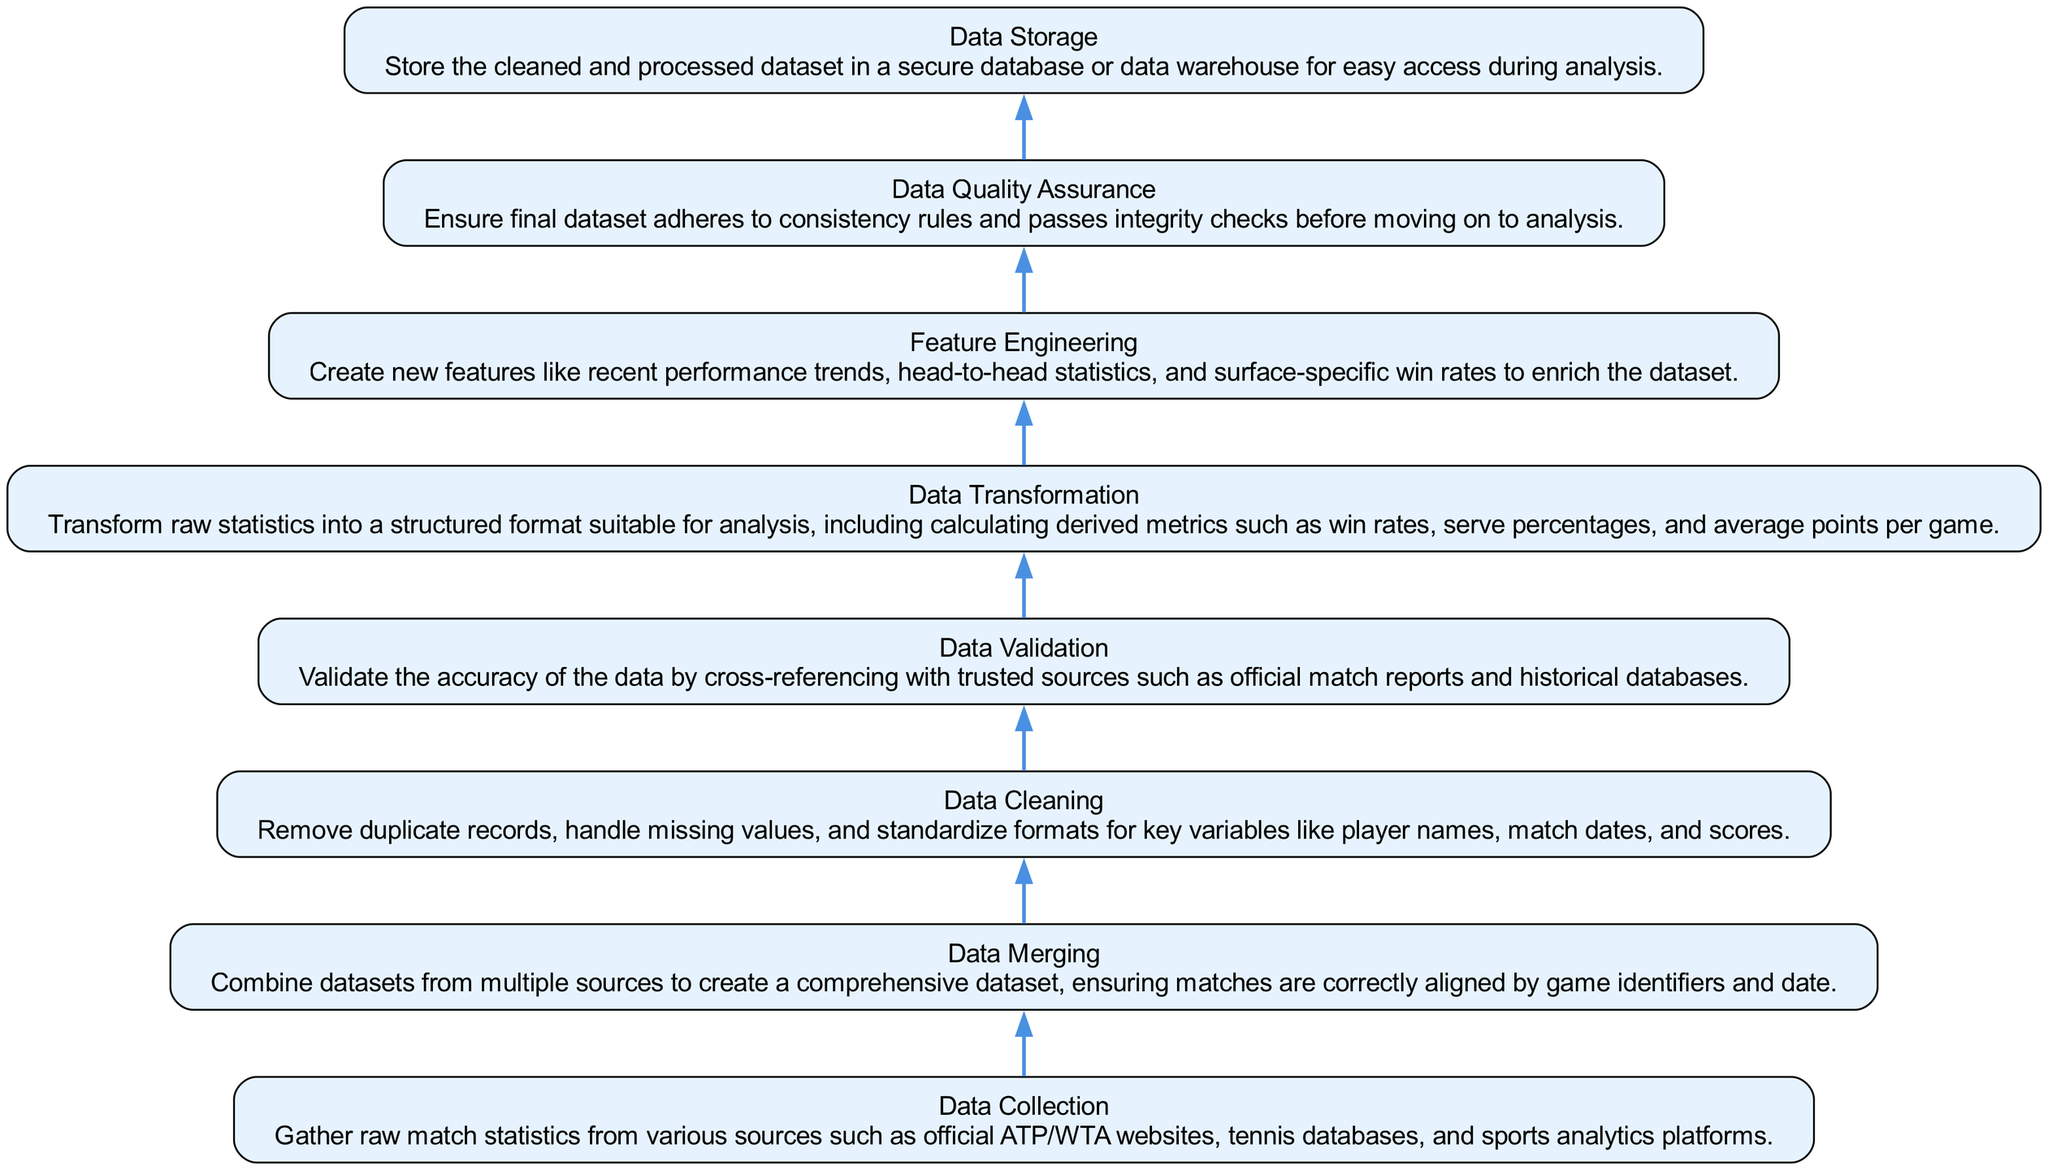What is the first step in the data cleaning process? The first step is "Data Collection", where raw match statistics are gathered from various sources.
Answer: Data Collection How many nodes are in the diagram? There are eight nodes, each representing a distinct step in the data cleaning process.
Answer: Eight What does the edge represent between "Data Merging" and "Data Cleaning"? The edge indicates a flow from "Data Merging" to "Data Cleaning", showing that data merging precedes the cleaning step.
Answer: Flow Which step follows "Data Validation"? "Data Transformation" follows "Data Validation" as the next step in the process.
Answer: Data Transformation What is the purpose of "Feature Engineering"? "Feature Engineering" is intended to create new features to enrich the dataset, enhancing the analysis potential.
Answer: Create new features What is the relationship between "Data Quality Assurance" and "Data Storage"? "Data Quality Assurance" must be completed before "Data Storage", ensuring only high-quality data is stored.
Answer: Quality assurance precedes storage Which step is concerned with addressing missing values? "Data Cleaning" specifically addresses removing duplicate records, handling missing values, and standardizing formats.
Answer: Data Cleaning Why is "Data Validation" important? "Data Validation" is important to verify the accuracy of the data by cross-referencing with trusted sources to maintain integrity.
Answer: Verify accuracy What is the last step in the process? The last step is "Data Storage", where the cleaned and processed dataset is stored for access during analysis.
Answer: Data Storage 